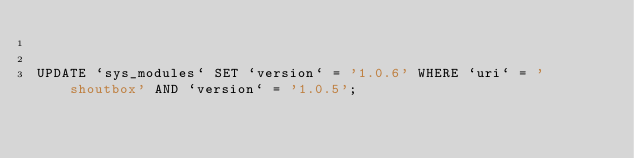<code> <loc_0><loc_0><loc_500><loc_500><_SQL_>

UPDATE `sys_modules` SET `version` = '1.0.6' WHERE `uri` = 'shoutbox' AND `version` = '1.0.5';

</code> 